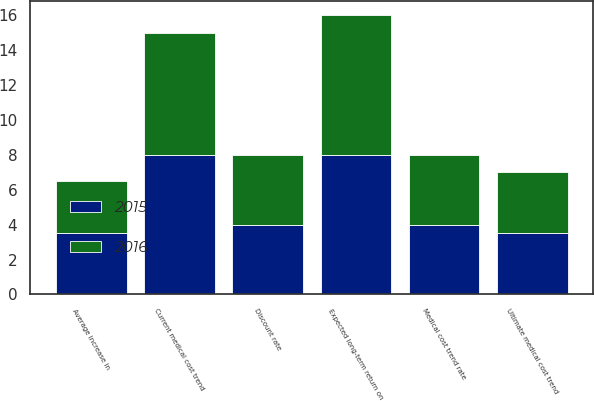<chart> <loc_0><loc_0><loc_500><loc_500><stacked_bar_chart><ecel><fcel>Discount rate<fcel>Average increase in<fcel>Expected long-term return on<fcel>Current medical cost trend<fcel>Ultimate medical cost trend<fcel>Medical cost trend rate<nl><fcel>2016<fcel>4<fcel>3<fcel>8<fcel>7<fcel>3.5<fcel>4<nl><fcel>2015<fcel>4<fcel>3.5<fcel>8<fcel>8<fcel>3.5<fcel>4<nl></chart> 